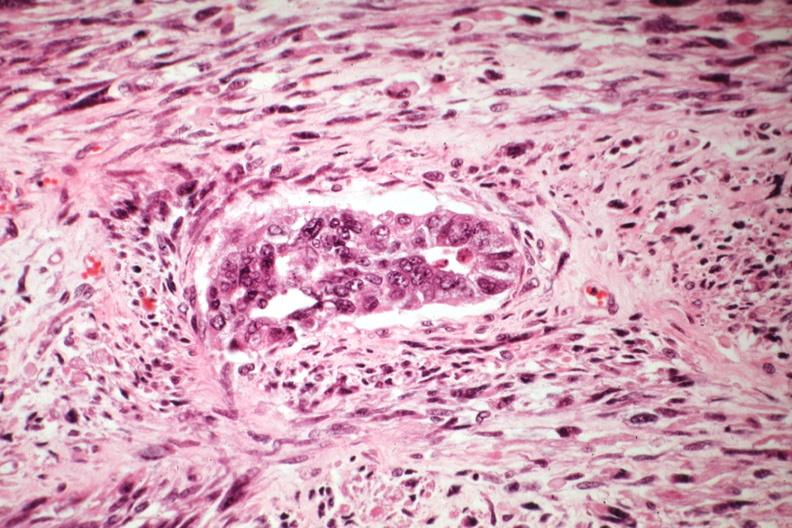s mixed mesodermal tumor present?
Answer the question using a single word or phrase. Yes 